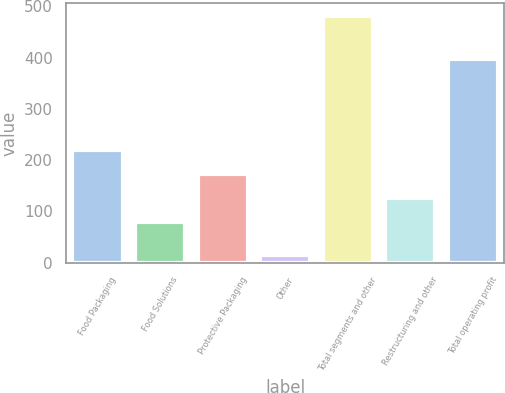<chart> <loc_0><loc_0><loc_500><loc_500><bar_chart><fcel>Food Packaging<fcel>Food Solutions<fcel>Protective Packaging<fcel>Other<fcel>Total segments and other<fcel>Restructuring and other<fcel>Total operating profit<nl><fcel>219.98<fcel>80<fcel>173.32<fcel>15<fcel>481.6<fcel>126.66<fcel>396.5<nl></chart> 